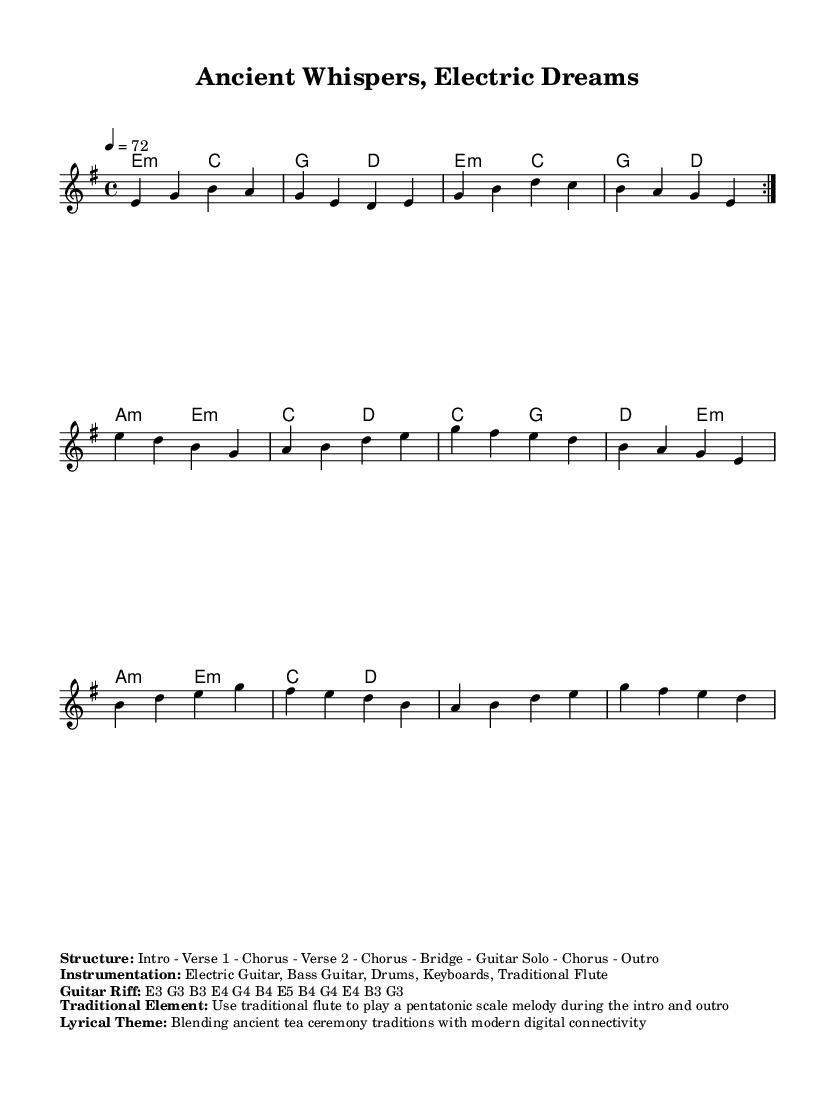What is the key signature of this music? The key signature is E minor, which contains one sharp (F#) and is indicated at the beginning of the staff.
Answer: E minor What is the time signature of the piece? The time signature shown at the beginning is 4/4, meaning there are four beats in each measure.
Answer: 4/4 What is the tempo marking indicated in the sheet music? The tempo marking specifies a speed of quarter note equals 72 beats per minute. This is indicated near the beginning of the score.
Answer: 72 How many verses does this piece have? The structure listed specifies there are two verses in the order: Intro - Verse 1 - Chorus - Verse 2 - Chorus - Bridge - Guitar Solo - Chorus - Outro, totaling two verses.
Answer: Two What type of instrumentation is used in this piece? The instrumentation is noted as Electric Guitar, Bass Guitar, Drums, Keyboards, and Traditional Flute, all of which play essential roles in a hard rock ballad.
Answer: Electric Guitar, Bass Guitar, Drums, Keyboards, Traditional Flute What traditional element is incorporated in the music? The traditional element involves using the flute to play a pentatonic scale melody during the intro and outro, which connects to cultural traditions.
Answer: Pentatonic scale melody What is the lyrical theme of this song? The lyrical theme blends the concept of ancient tea ceremony traditions with modern digital connectivity, highlighting a fusion of old and new cultural practices.
Answer: Blending ancient tea ceremony traditions with modern digital connectivity 